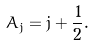Convert formula to latex. <formula><loc_0><loc_0><loc_500><loc_500>A _ { j } = j + \frac { 1 } { 2 } .</formula> 